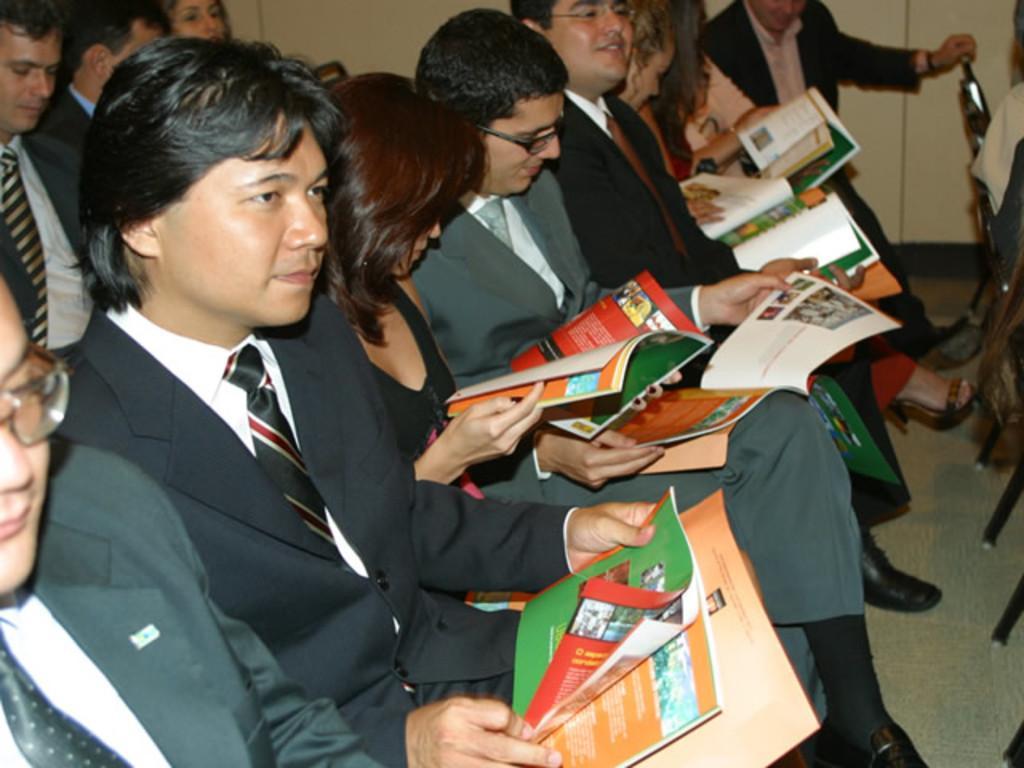Please provide a concise description of this image. In this picture we can see a group of people sitting on chairs and some people are holding books. Behind the people there is a wall. 